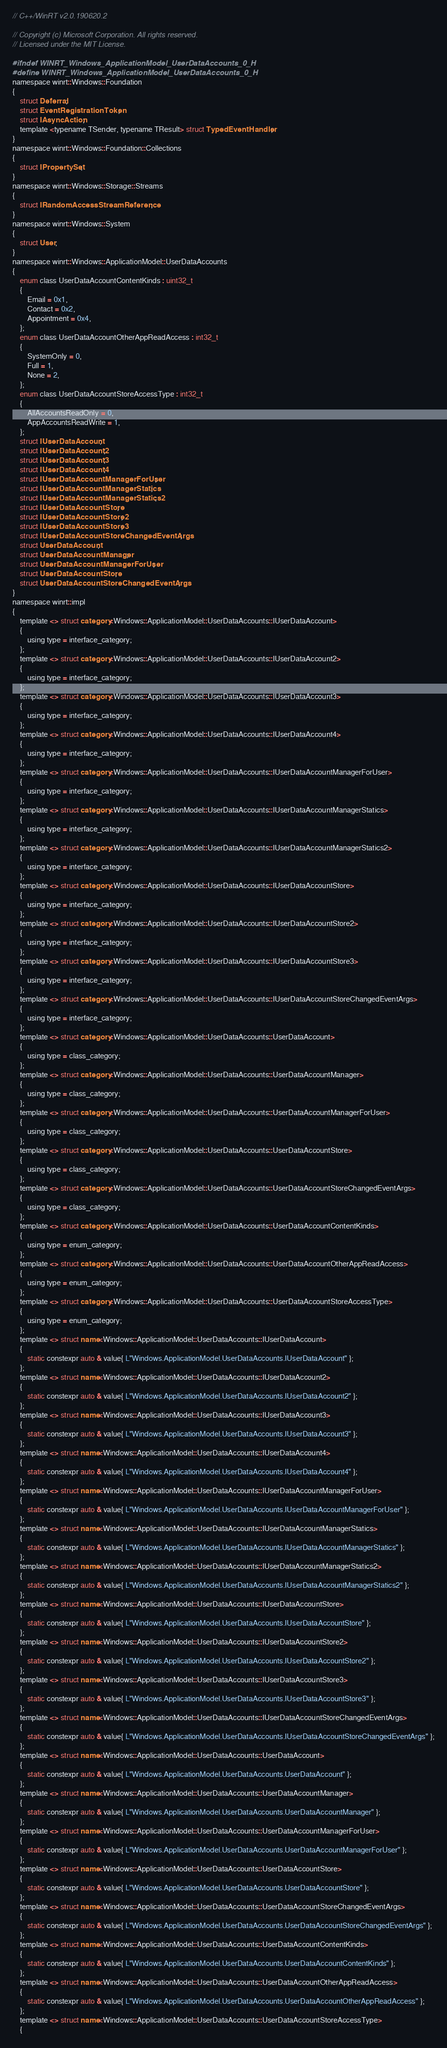Convert code to text. <code><loc_0><loc_0><loc_500><loc_500><_C_>// C++/WinRT v2.0.190620.2

// Copyright (c) Microsoft Corporation. All rights reserved.
// Licensed under the MIT License.

#ifndef WINRT_Windows_ApplicationModel_UserDataAccounts_0_H
#define WINRT_Windows_ApplicationModel_UserDataAccounts_0_H
namespace winrt::Windows::Foundation
{
    struct Deferral;
    struct EventRegistrationToken;
    struct IAsyncAction;
    template <typename TSender, typename TResult> struct TypedEventHandler;
}
namespace winrt::Windows::Foundation::Collections
{
    struct IPropertySet;
}
namespace winrt::Windows::Storage::Streams
{
    struct IRandomAccessStreamReference;
}
namespace winrt::Windows::System
{
    struct User;
}
namespace winrt::Windows::ApplicationModel::UserDataAccounts
{
    enum class UserDataAccountContentKinds : uint32_t
    {
        Email = 0x1,
        Contact = 0x2,
        Appointment = 0x4,
    };
    enum class UserDataAccountOtherAppReadAccess : int32_t
    {
        SystemOnly = 0,
        Full = 1,
        None = 2,
    };
    enum class UserDataAccountStoreAccessType : int32_t
    {
        AllAccountsReadOnly = 0,
        AppAccountsReadWrite = 1,
    };
    struct IUserDataAccount;
    struct IUserDataAccount2;
    struct IUserDataAccount3;
    struct IUserDataAccount4;
    struct IUserDataAccountManagerForUser;
    struct IUserDataAccountManagerStatics;
    struct IUserDataAccountManagerStatics2;
    struct IUserDataAccountStore;
    struct IUserDataAccountStore2;
    struct IUserDataAccountStore3;
    struct IUserDataAccountStoreChangedEventArgs;
    struct UserDataAccount;
    struct UserDataAccountManager;
    struct UserDataAccountManagerForUser;
    struct UserDataAccountStore;
    struct UserDataAccountStoreChangedEventArgs;
}
namespace winrt::impl
{
    template <> struct category<Windows::ApplicationModel::UserDataAccounts::IUserDataAccount>
    {
        using type = interface_category;
    };
    template <> struct category<Windows::ApplicationModel::UserDataAccounts::IUserDataAccount2>
    {
        using type = interface_category;
    };
    template <> struct category<Windows::ApplicationModel::UserDataAccounts::IUserDataAccount3>
    {
        using type = interface_category;
    };
    template <> struct category<Windows::ApplicationModel::UserDataAccounts::IUserDataAccount4>
    {
        using type = interface_category;
    };
    template <> struct category<Windows::ApplicationModel::UserDataAccounts::IUserDataAccountManagerForUser>
    {
        using type = interface_category;
    };
    template <> struct category<Windows::ApplicationModel::UserDataAccounts::IUserDataAccountManagerStatics>
    {
        using type = interface_category;
    };
    template <> struct category<Windows::ApplicationModel::UserDataAccounts::IUserDataAccountManagerStatics2>
    {
        using type = interface_category;
    };
    template <> struct category<Windows::ApplicationModel::UserDataAccounts::IUserDataAccountStore>
    {
        using type = interface_category;
    };
    template <> struct category<Windows::ApplicationModel::UserDataAccounts::IUserDataAccountStore2>
    {
        using type = interface_category;
    };
    template <> struct category<Windows::ApplicationModel::UserDataAccounts::IUserDataAccountStore3>
    {
        using type = interface_category;
    };
    template <> struct category<Windows::ApplicationModel::UserDataAccounts::IUserDataAccountStoreChangedEventArgs>
    {
        using type = interface_category;
    };
    template <> struct category<Windows::ApplicationModel::UserDataAccounts::UserDataAccount>
    {
        using type = class_category;
    };
    template <> struct category<Windows::ApplicationModel::UserDataAccounts::UserDataAccountManager>
    {
        using type = class_category;
    };
    template <> struct category<Windows::ApplicationModel::UserDataAccounts::UserDataAccountManagerForUser>
    {
        using type = class_category;
    };
    template <> struct category<Windows::ApplicationModel::UserDataAccounts::UserDataAccountStore>
    {
        using type = class_category;
    };
    template <> struct category<Windows::ApplicationModel::UserDataAccounts::UserDataAccountStoreChangedEventArgs>
    {
        using type = class_category;
    };
    template <> struct category<Windows::ApplicationModel::UserDataAccounts::UserDataAccountContentKinds>
    {
        using type = enum_category;
    };
    template <> struct category<Windows::ApplicationModel::UserDataAccounts::UserDataAccountOtherAppReadAccess>
    {
        using type = enum_category;
    };
    template <> struct category<Windows::ApplicationModel::UserDataAccounts::UserDataAccountStoreAccessType>
    {
        using type = enum_category;
    };
    template <> struct name<Windows::ApplicationModel::UserDataAccounts::IUserDataAccount>
    {
        static constexpr auto & value{ L"Windows.ApplicationModel.UserDataAccounts.IUserDataAccount" };
    };
    template <> struct name<Windows::ApplicationModel::UserDataAccounts::IUserDataAccount2>
    {
        static constexpr auto & value{ L"Windows.ApplicationModel.UserDataAccounts.IUserDataAccount2" };
    };
    template <> struct name<Windows::ApplicationModel::UserDataAccounts::IUserDataAccount3>
    {
        static constexpr auto & value{ L"Windows.ApplicationModel.UserDataAccounts.IUserDataAccount3" };
    };
    template <> struct name<Windows::ApplicationModel::UserDataAccounts::IUserDataAccount4>
    {
        static constexpr auto & value{ L"Windows.ApplicationModel.UserDataAccounts.IUserDataAccount4" };
    };
    template <> struct name<Windows::ApplicationModel::UserDataAccounts::IUserDataAccountManagerForUser>
    {
        static constexpr auto & value{ L"Windows.ApplicationModel.UserDataAccounts.IUserDataAccountManagerForUser" };
    };
    template <> struct name<Windows::ApplicationModel::UserDataAccounts::IUserDataAccountManagerStatics>
    {
        static constexpr auto & value{ L"Windows.ApplicationModel.UserDataAccounts.IUserDataAccountManagerStatics" };
    };
    template <> struct name<Windows::ApplicationModel::UserDataAccounts::IUserDataAccountManagerStatics2>
    {
        static constexpr auto & value{ L"Windows.ApplicationModel.UserDataAccounts.IUserDataAccountManagerStatics2" };
    };
    template <> struct name<Windows::ApplicationModel::UserDataAccounts::IUserDataAccountStore>
    {
        static constexpr auto & value{ L"Windows.ApplicationModel.UserDataAccounts.IUserDataAccountStore" };
    };
    template <> struct name<Windows::ApplicationModel::UserDataAccounts::IUserDataAccountStore2>
    {
        static constexpr auto & value{ L"Windows.ApplicationModel.UserDataAccounts.IUserDataAccountStore2" };
    };
    template <> struct name<Windows::ApplicationModel::UserDataAccounts::IUserDataAccountStore3>
    {
        static constexpr auto & value{ L"Windows.ApplicationModel.UserDataAccounts.IUserDataAccountStore3" };
    };
    template <> struct name<Windows::ApplicationModel::UserDataAccounts::IUserDataAccountStoreChangedEventArgs>
    {
        static constexpr auto & value{ L"Windows.ApplicationModel.UserDataAccounts.IUserDataAccountStoreChangedEventArgs" };
    };
    template <> struct name<Windows::ApplicationModel::UserDataAccounts::UserDataAccount>
    {
        static constexpr auto & value{ L"Windows.ApplicationModel.UserDataAccounts.UserDataAccount" };
    };
    template <> struct name<Windows::ApplicationModel::UserDataAccounts::UserDataAccountManager>
    {
        static constexpr auto & value{ L"Windows.ApplicationModel.UserDataAccounts.UserDataAccountManager" };
    };
    template <> struct name<Windows::ApplicationModel::UserDataAccounts::UserDataAccountManagerForUser>
    {
        static constexpr auto & value{ L"Windows.ApplicationModel.UserDataAccounts.UserDataAccountManagerForUser" };
    };
    template <> struct name<Windows::ApplicationModel::UserDataAccounts::UserDataAccountStore>
    {
        static constexpr auto & value{ L"Windows.ApplicationModel.UserDataAccounts.UserDataAccountStore" };
    };
    template <> struct name<Windows::ApplicationModel::UserDataAccounts::UserDataAccountStoreChangedEventArgs>
    {
        static constexpr auto & value{ L"Windows.ApplicationModel.UserDataAccounts.UserDataAccountStoreChangedEventArgs" };
    };
    template <> struct name<Windows::ApplicationModel::UserDataAccounts::UserDataAccountContentKinds>
    {
        static constexpr auto & value{ L"Windows.ApplicationModel.UserDataAccounts.UserDataAccountContentKinds" };
    };
    template <> struct name<Windows::ApplicationModel::UserDataAccounts::UserDataAccountOtherAppReadAccess>
    {
        static constexpr auto & value{ L"Windows.ApplicationModel.UserDataAccounts.UserDataAccountOtherAppReadAccess" };
    };
    template <> struct name<Windows::ApplicationModel::UserDataAccounts::UserDataAccountStoreAccessType>
    {</code> 